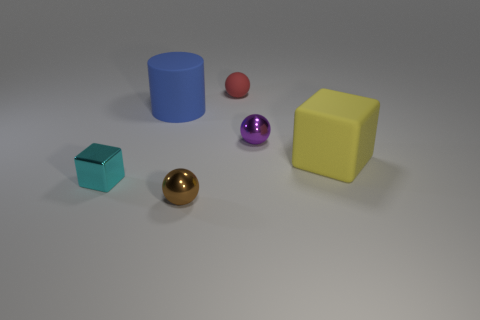Is there a brown ball that has the same size as the yellow cube?
Your answer should be compact. No. What number of cyan objects are metallic cubes or small metallic objects?
Ensure brevity in your answer.  1. How many tiny shiny spheres are the same color as the large cylinder?
Ensure brevity in your answer.  0. Is there anything else that has the same shape as the big blue matte object?
Your answer should be compact. No. How many cylinders are either tiny cyan things or shiny objects?
Give a very brief answer. 0. There is a tiny ball that is behind the big cylinder; what is its color?
Ensure brevity in your answer.  Red. There is a brown metal object that is the same size as the purple object; what shape is it?
Provide a succinct answer. Sphere. There is a brown sphere; how many blue cylinders are to the left of it?
Ensure brevity in your answer.  1. How many objects are tiny rubber balls or metallic blocks?
Provide a short and direct response. 2. The metallic thing that is both behind the small brown thing and right of the cyan metallic block has what shape?
Your response must be concise. Sphere. 